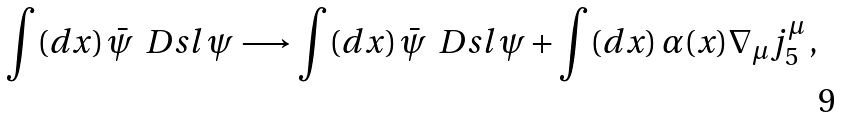Convert formula to latex. <formula><loc_0><loc_0><loc_500><loc_500>\int ( d x ) \, \bar { \psi } \, \ D s l \, \psi \longrightarrow \int ( d x ) \, \bar { \psi } \, \ D s l \, \psi + \int ( d x ) \, \alpha ( x ) \nabla _ { \mu } j _ { 5 } ^ { \mu } \, ,</formula> 